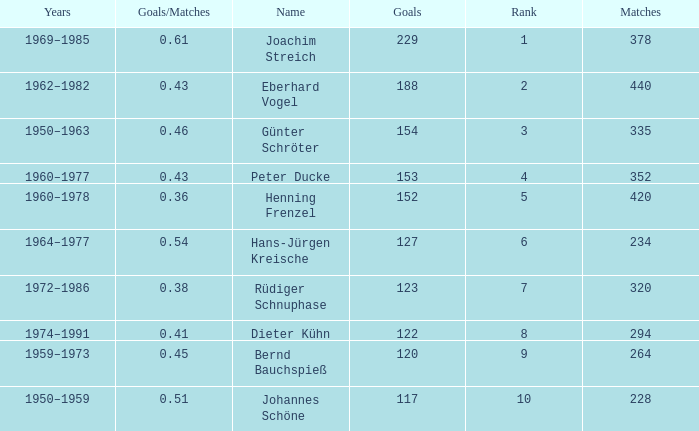How many goals/matches have 153 as the goals with matches greater than 352? None. 